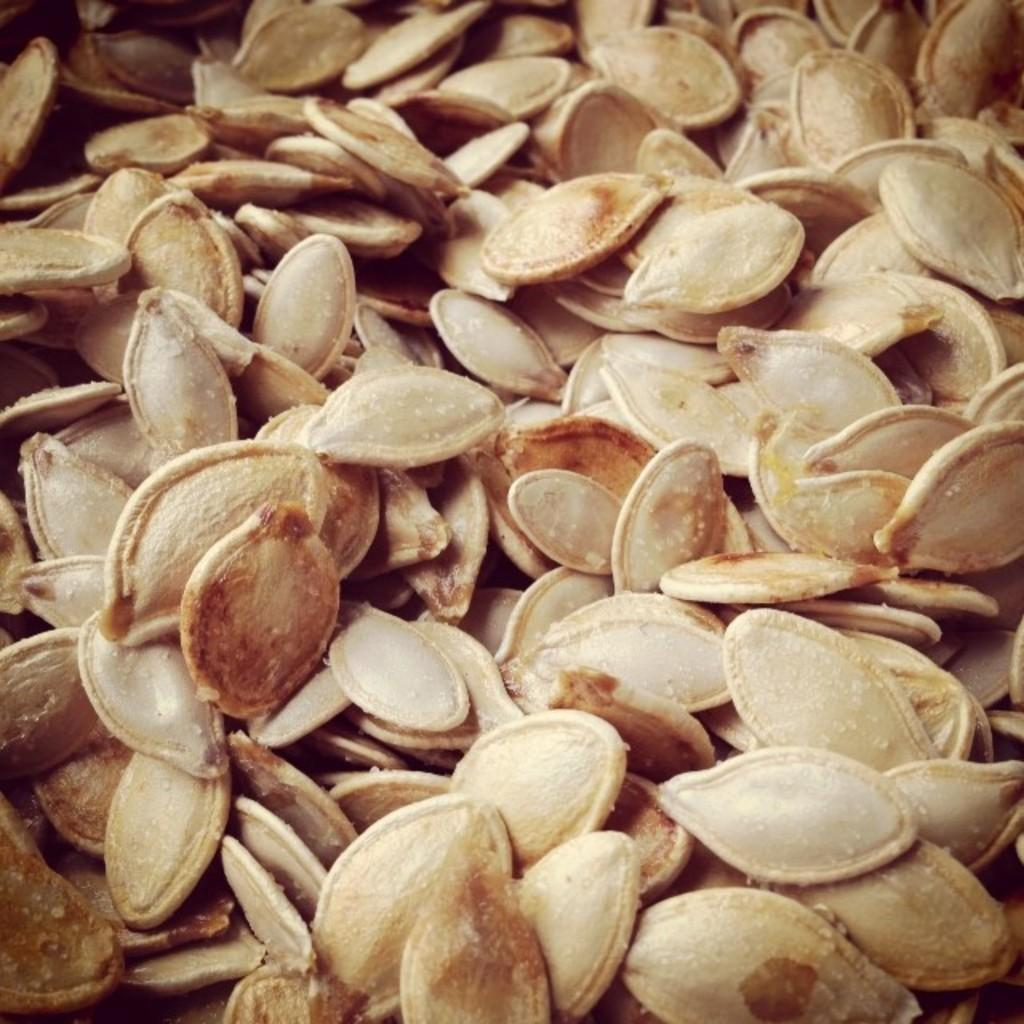What type of seeds are visible in the image? There are pumpkin seeds in the image. How much did the sisters pay for the pumpkin seeds in the image? There is no information about sisters or payment in the image, as it only shows pumpkin seeds. 